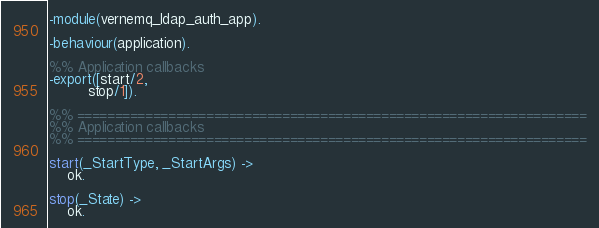<code> <loc_0><loc_0><loc_500><loc_500><_Erlang_>-module(vernemq_ldap_auth_app).

-behaviour(application).

%% Application callbacks
-export([start/2,
         stop/1]).

%% ===================================================================
%% Application callbacks
%% ===================================================================

start(_StartType, _StartArgs) ->
    ok.

stop(_State) ->
    ok.
</code> 